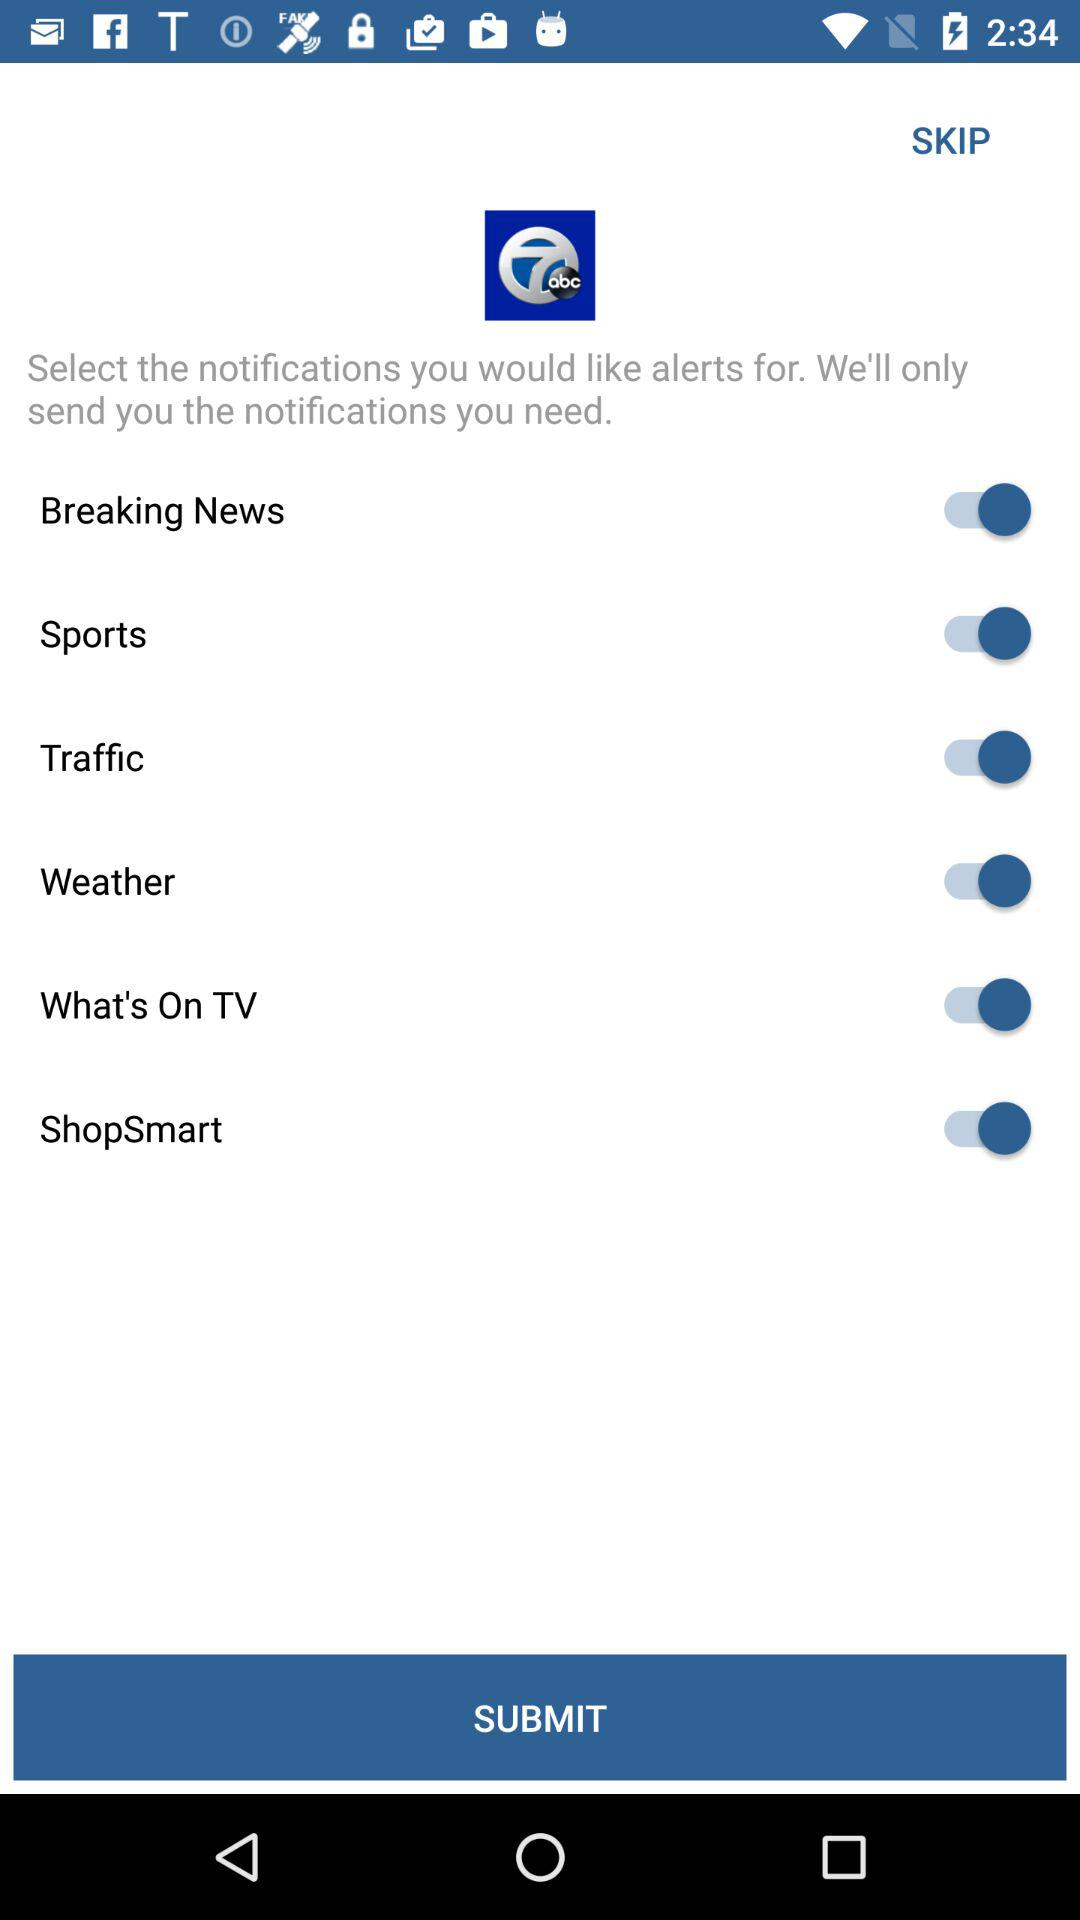How many of the notifications are for sports?
Answer the question using a single word or phrase. 1 